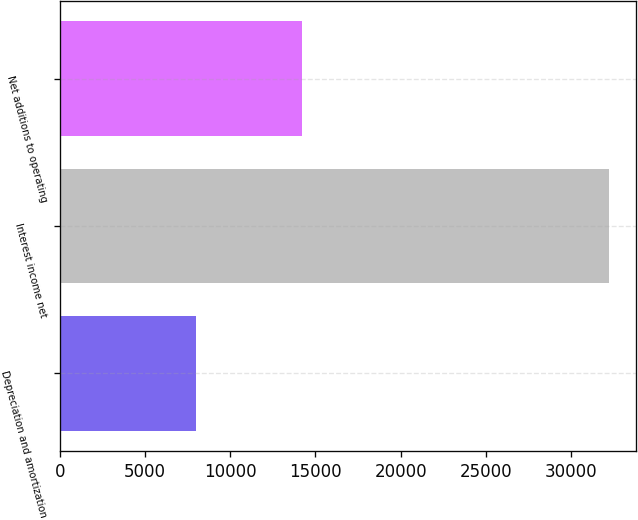Convert chart to OTSL. <chart><loc_0><loc_0><loc_500><loc_500><bar_chart><fcel>Depreciation and amortization<fcel>Interest income net<fcel>Net additions to operating<nl><fcel>7958<fcel>32218<fcel>14215<nl></chart> 